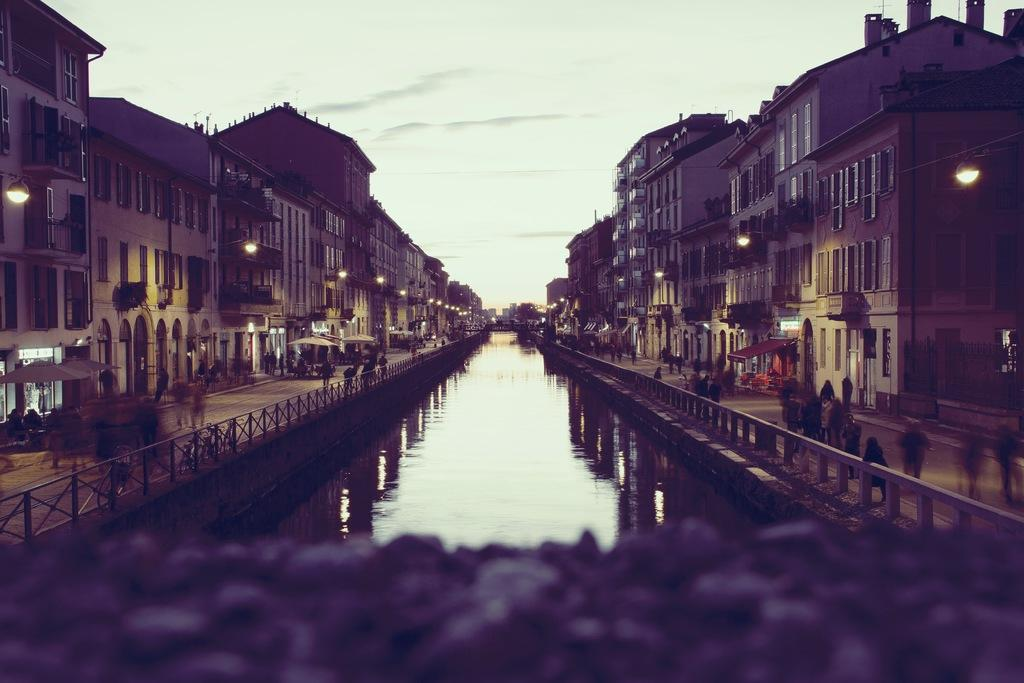What is the main feature of the image? The main feature of the image is water. What can be seen on both sides of the water? There are buildings on both sides of the water. What else is visible in the image? There are lights, people standing on the road, and tents in the image. What is visible in the background of the image? The sky is visible in the background of the image. What type of glass is being used by the people standing on the sidewalk in the image? There is no mention of a sidewalk or glass in the image; it features water, buildings, lights, people, tents, and the sky. 